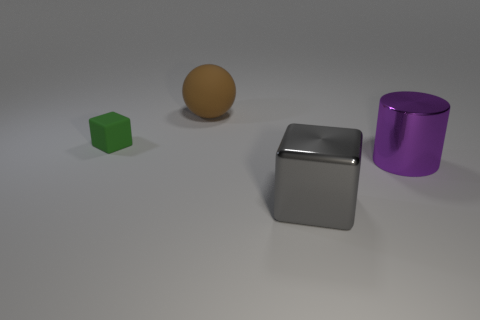Add 1 yellow balls. How many objects exist? 5 Subtract all cylinders. How many objects are left? 3 Subtract 0 red cylinders. How many objects are left? 4 Subtract all blue matte cylinders. Subtract all large gray metal objects. How many objects are left? 3 Add 3 large objects. How many large objects are left? 6 Add 1 gray things. How many gray things exist? 2 